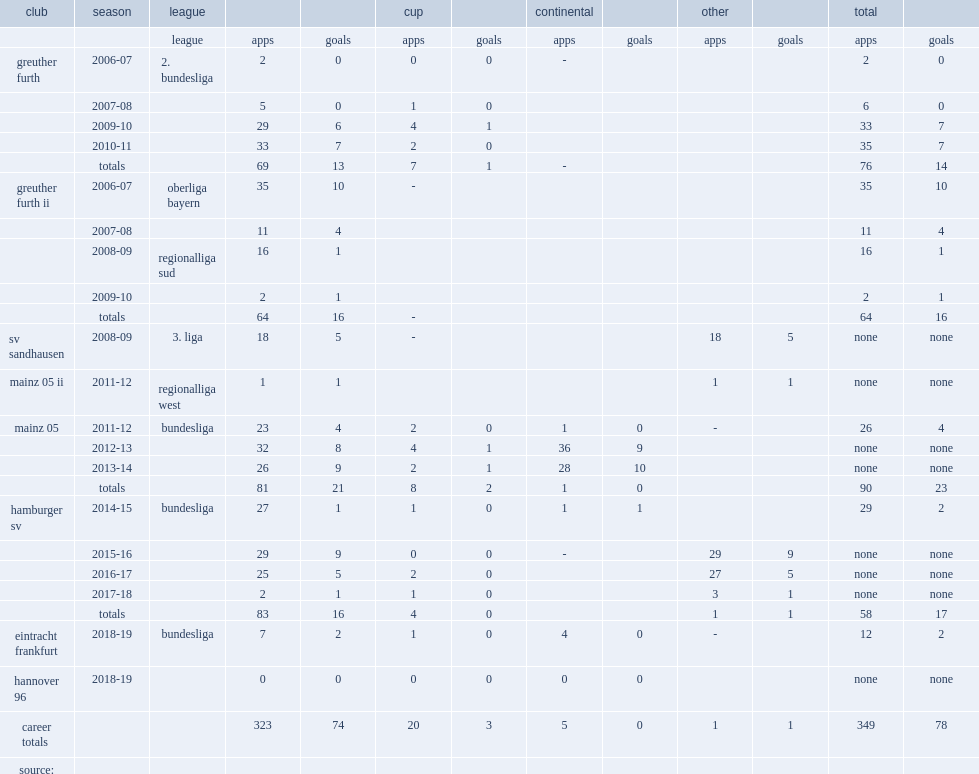In the 2017-18 season, which league did muller transfer from hamburger sv? Bundesliga. 